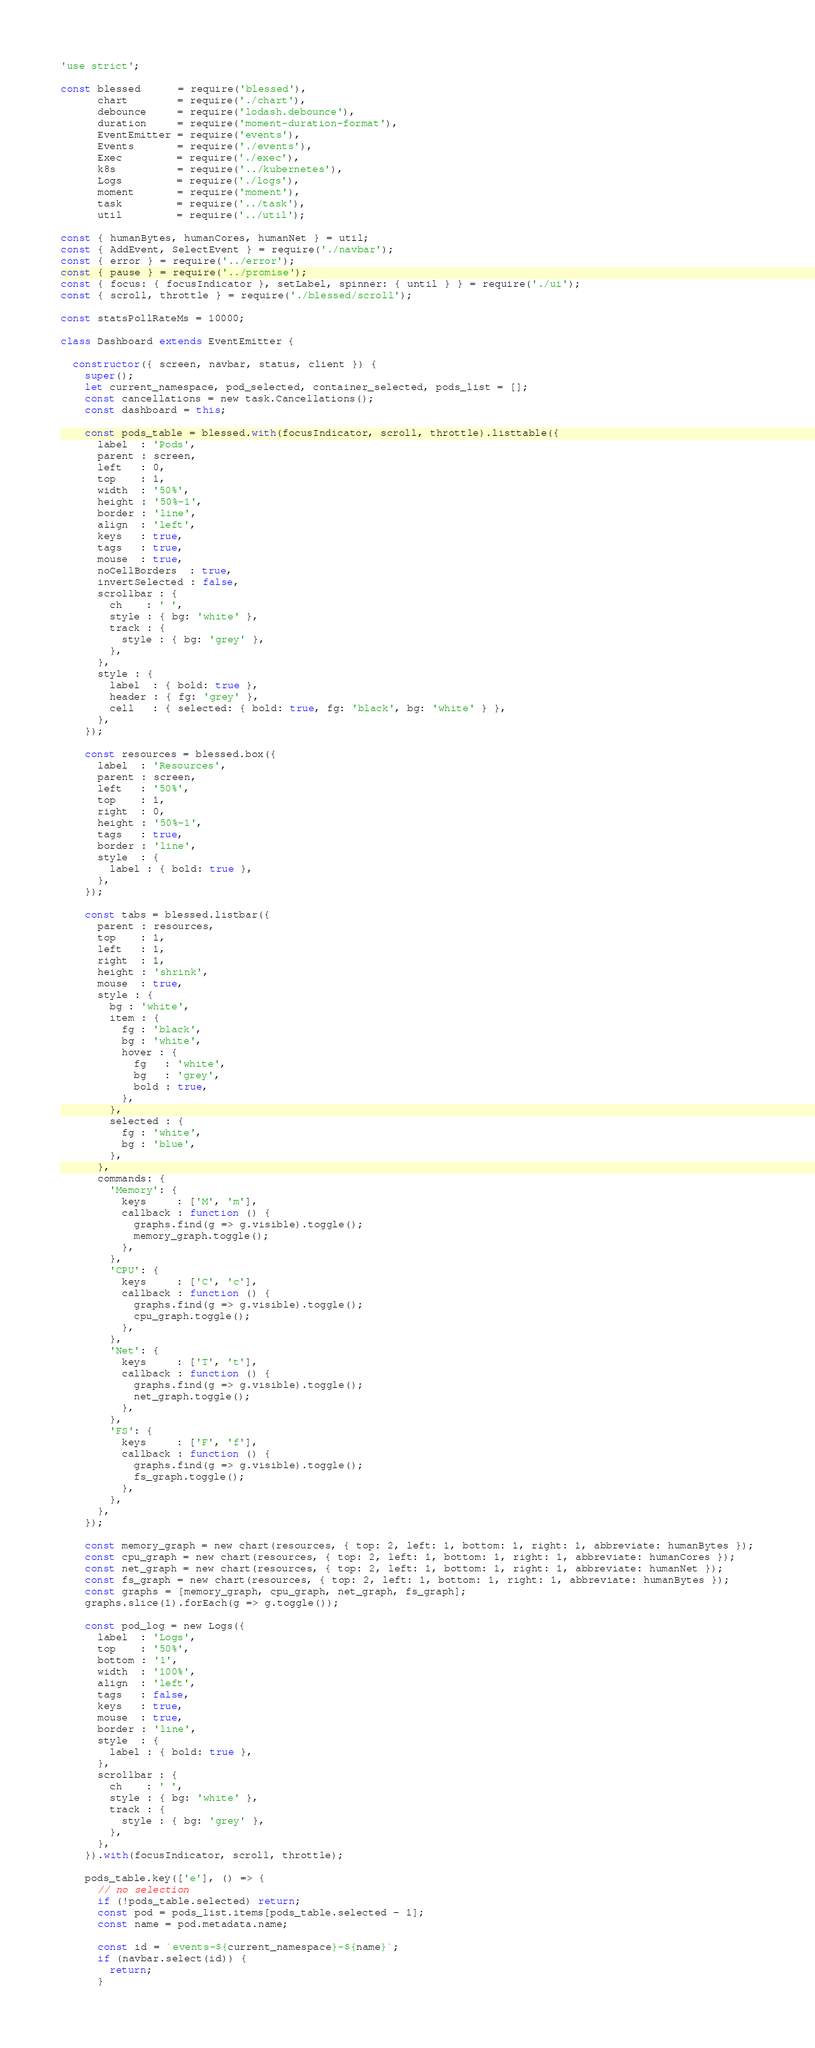<code> <loc_0><loc_0><loc_500><loc_500><_JavaScript_>'use strict';

const blessed      = require('blessed'),
      chart        = require('./chart'),
      debounce     = require('lodash.debounce'),
      duration     = require('moment-duration-format'),
      EventEmitter = require('events'),
      Events       = require('./events'),
      Exec         = require('./exec'),
      k8s          = require('../kubernetes'),
      Logs         = require('./logs'),
      moment       = require('moment'),
      task         = require('../task'),
      util         = require('../util');

const { humanBytes, humanCores, humanNet } = util;
const { AddEvent, SelectEvent } = require('./navbar');
const { error } = require('../error');
const { pause } = require('../promise');
const { focus: { focusIndicator }, setLabel, spinner: { until } } = require('./ui');
const { scroll, throttle } = require('./blessed/scroll');

const statsPollRateMs = 10000;

class Dashboard extends EventEmitter {

  constructor({ screen, navbar, status, client }) {
    super();
    let current_namespace, pod_selected, container_selected, pods_list = [];
    const cancellations = new task.Cancellations();
    const dashboard = this;

    const pods_table = blessed.with(focusIndicator, scroll, throttle).listtable({
      label  : 'Pods',
      parent : screen,
      left   : 0,
      top    : 1,
      width  : '50%',
      height : '50%-1',
      border : 'line',
      align  : 'left',
      keys   : true,
      tags   : true,
      mouse  : true,
      noCellBorders  : true,
      invertSelected : false,
      scrollbar : {
        ch    : ' ',
        style : { bg: 'white' },
        track : {
          style : { bg: 'grey' },
        },
      },
      style : {
        label  : { bold: true },
        header : { fg: 'grey' },
        cell   : { selected: { bold: true, fg: 'black', bg: 'white' } },
      },
    });

    const resources = blessed.box({
      label  : 'Resources',
      parent : screen,
      left   : '50%',
      top    : 1,
      right  : 0,
      height : '50%-1',
      tags   : true,
      border : 'line',
      style  : {
        label : { bold: true },
      },
    });

    const tabs = blessed.listbar({
      parent : resources,
      top    : 1,
      left   : 1,
      right  : 1,
      height : 'shrink',
      mouse  : true,
      style : {
        bg : 'white',
        item : {
          fg : 'black',
          bg : 'white',
          hover : {
            fg   : 'white',
            bg   : 'grey',
            bold : true,
          },
        },
        selected : {
          fg : 'white',
          bg : 'blue',
        },
      },
      commands: {
        'Memory': {
          keys     : ['M', 'm'],
          callback : function () {
            graphs.find(g => g.visible).toggle();
            memory_graph.toggle();
          },
        },
        'CPU': {
          keys     : ['C', 'c'],
          callback : function () {
            graphs.find(g => g.visible).toggle();
            cpu_graph.toggle();
          },
        },
        'Net': {
          keys     : ['T', 't'],
          callback : function () {
            graphs.find(g => g.visible).toggle();
            net_graph.toggle();
          },
        },
        'FS': {
          keys     : ['F', 'f'],
          callback : function () {
            graphs.find(g => g.visible).toggle();
            fs_graph.toggle();
          },
        },
      },
    });

    const memory_graph = new chart(resources, { top: 2, left: 1, bottom: 1, right: 1, abbreviate: humanBytes });
    const cpu_graph = new chart(resources, { top: 2, left: 1, bottom: 1, right: 1, abbreviate: humanCores });
    const net_graph = new chart(resources, { top: 2, left: 1, bottom: 1, right: 1, abbreviate: humanNet });
    const fs_graph = new chart(resources, { top: 2, left: 1, bottom: 1, right: 1, abbreviate: humanBytes });
    const graphs = [memory_graph, cpu_graph, net_graph, fs_graph];
    graphs.slice(1).forEach(g => g.toggle());

    const pod_log = new Logs({
      label  : 'Logs',
      top    : '50%',
      bottom : '1',
      width  : '100%',
      align  : 'left',
      tags   : false,
      keys   : true,
      mouse  : true,
      border : 'line',
      style  : {
        label : { bold: true },
      },
      scrollbar : {
        ch    : ' ',
        style : { bg: 'white' },
        track : {
          style : { bg: 'grey' },
        },
      },
    }).with(focusIndicator, scroll, throttle);

    pods_table.key(['e'], () => {
      // no selection
      if (!pods_table.selected) return;
      const pod = pods_list.items[pods_table.selected - 1];
      const name = pod.metadata.name;

      const id = `events-${current_namespace}-${name}`;
      if (navbar.select(id)) {
        return;
      }</code> 